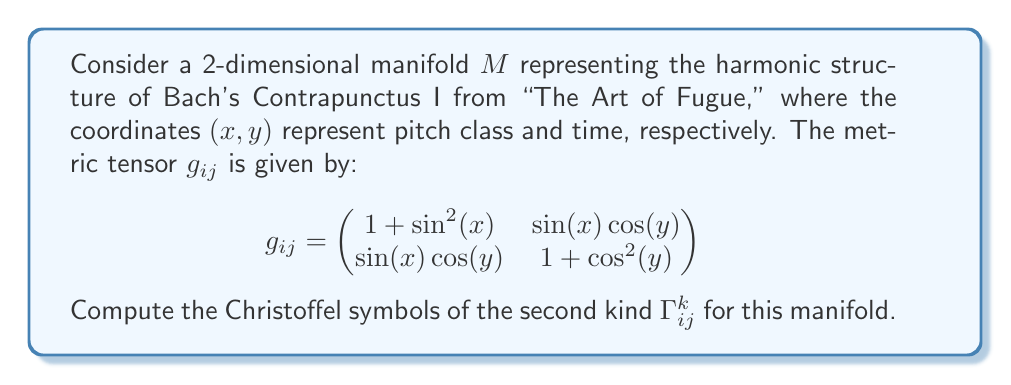Teach me how to tackle this problem. To compute the Christoffel symbols, we'll follow these steps:

1) First, we need to calculate the inverse metric tensor $g^{ij}$. The determinant of $g_{ij}$ is:

   $$\det(g_{ij}) = (1 + \sin^2(x))(1 + \cos^2(y)) - \sin^2(x)\cos^2(y)$$

2) The inverse metric tensor is:

   $$g^{ij} = \frac{1}{\det(g_{ij})} \begin{pmatrix}
   1 + \cos^2(y) & -\sin(x)\cos(y) \\
   -\sin(x)\cos(y) & 1 + \sin^2(x)
   \end{pmatrix}$$

3) The Christoffel symbols are given by the formula:

   $$\Gamma^k_{ij} = \frac{1}{2}g^{km}\left(\frac{\partial g_{mj}}{\partial x^i} + \frac{\partial g_{mi}}{\partial x^j} - \frac{\partial g_{ij}}{\partial x^m}\right)$$

4) We need to calculate the partial derivatives of $g_{ij}$:

   $$\frac{\partial g_{11}}{\partial x} = 2\sin(x)\cos(x)$$
   $$\frac{\partial g_{11}}{\partial y} = 0$$
   $$\frac{\partial g_{12}}{\partial x} = \cos(x)\cos(y)$$
   $$\frac{\partial g_{12}}{\partial y} = -\sin(x)\sin(y)$$
   $$\frac{\partial g_{22}}{\partial x} = 0$$
   $$\frac{\partial g_{22}}{\partial y} = -2\cos(y)\sin(y)$$

5) Now we can calculate each Christoffel symbol:

   $$\Gamma^1_{11} = \frac{1}{2}g^{11}\frac{\partial g_{11}}{\partial x} = \frac{(1 + \cos^2(y))\sin(x)\cos(x)}{\det(g_{ij})}$$

   $$\Gamma^1_{12} = \frac{1}{2}g^{11}\frac{\partial g_{12}}{\partial x} = \frac{(1 + \cos^2(y))\cos(x)\cos(y)}{2\det(g_{ij})}$$

   $$\Gamma^1_{22} = \frac{1}{2}g^{11}\frac{\partial g_{22}}{\partial x} - g^{12}\frac{\partial g_{12}}{\partial y} = \frac{\sin(x)\cos(y)\sin(y)}{\det(g_{ij})}$$

   $$\Gamma^2_{11} = \frac{1}{2}g^{22}\frac{\partial g_{11}}{\partial y} - g^{21}\frac{\partial g_{12}}{\partial x} = -\frac{(1 + \sin^2(x))\cos(x)\cos(y)}{\det(g_{ij})}$$

   $$\Gamma^2_{12} = \frac{1}{2}g^{22}\frac{\partial g_{12}}{\partial y} = -\frac{(1 + \sin^2(x))\sin(x)\sin(y)}{2\det(g_{ij})}$$

   $$\Gamma^2_{22} = \frac{1}{2}g^{22}\frac{\partial g_{22}}{\partial y} = -\frac{(1 + \sin^2(x))\cos(y)\sin(y)}{\det(g_{ij})}$$

These are the Christoffel symbols of the second kind for the given manifold.
Answer: $$\Gamma^1_{11} = \frac{(1 + \cos^2(y))\sin(x)\cos(x)}{\det(g_{ij})}, \Gamma^1_{12} = \frac{(1 + \cos^2(y))\cos(x)\cos(y)}{2\det(g_{ij})}, \Gamma^1_{22} = \frac{\sin(x)\cos(y)\sin(y)}{\det(g_{ij})}, \Gamma^2_{11} = -\frac{(1 + \sin^2(x))\cos(x)\cos(y)}{\det(g_{ij})}, \Gamma^2_{12} = -\frac{(1 + \sin^2(x))\sin(x)\sin(y)}{2\det(g_{ij})}, \Gamma^2_{22} = -\frac{(1 + \sin^2(x))\cos(y)\sin(y)}{\det(g_{ij})}$$ 